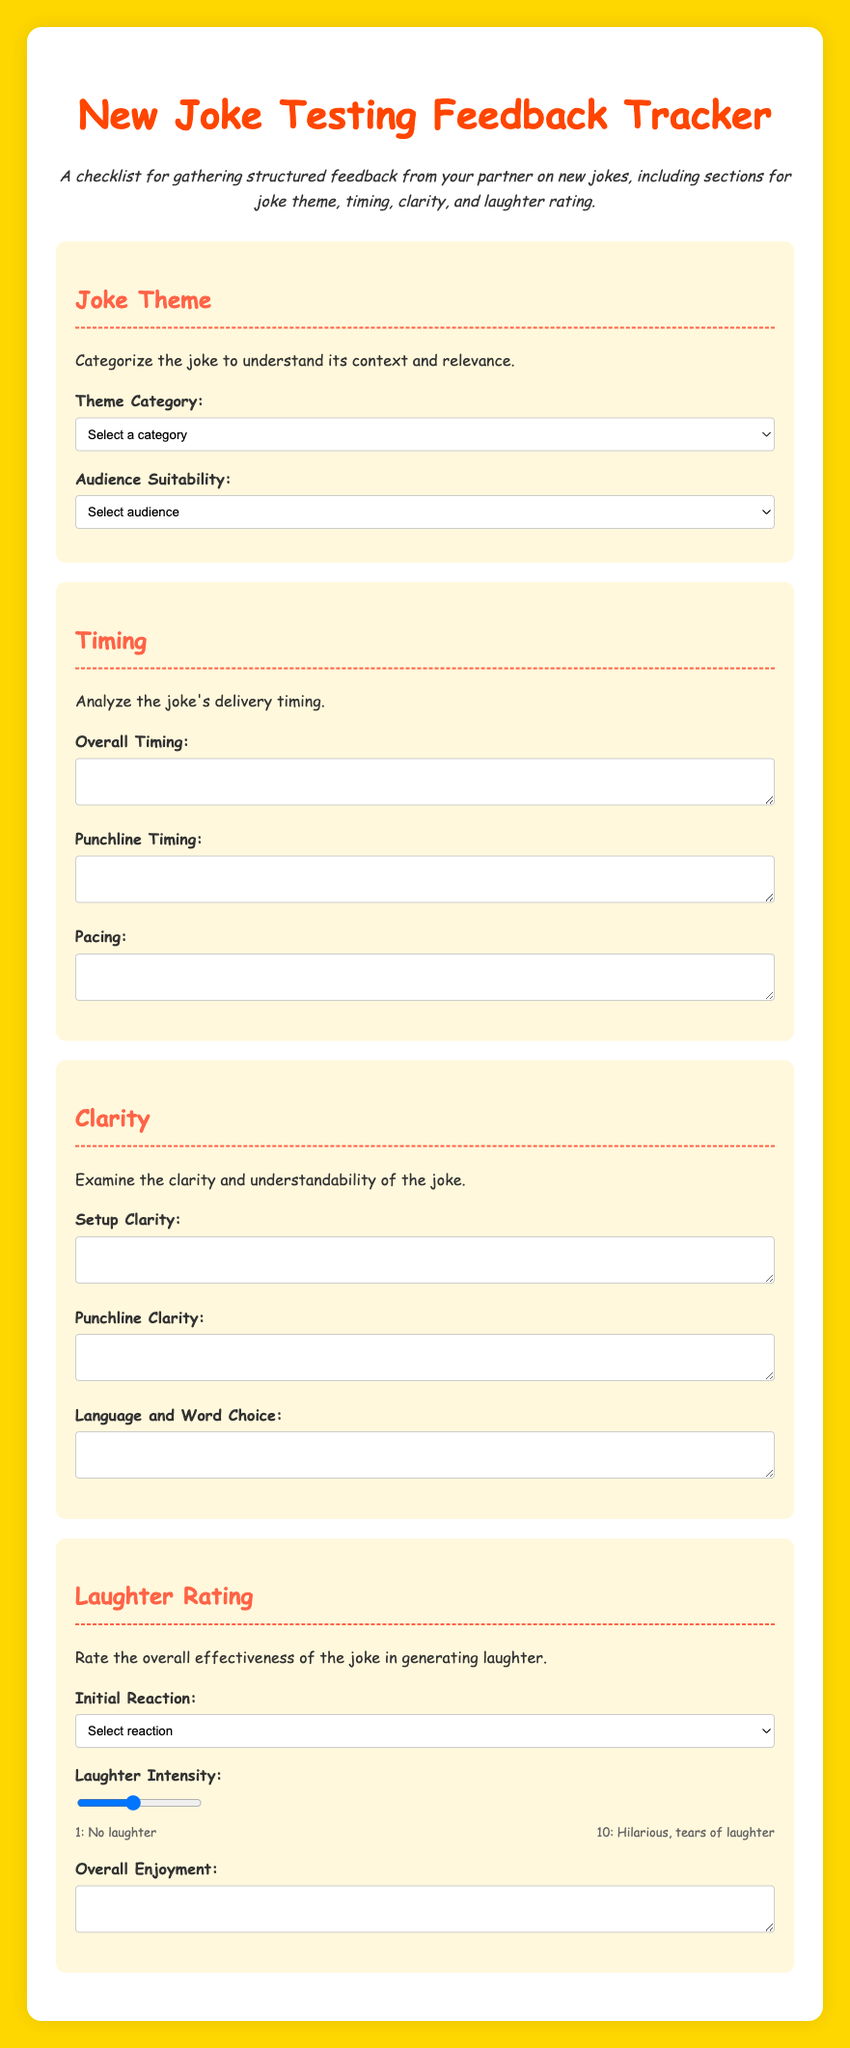What is the title of the document? The title of the document is provided in the header section of the HTML code.
Answer: New Joke Testing Feedback Tracker How many sections are there in the document? Each major topic is categorized into different sections; the code lists four distinct sections.
Answer: 4 What category options are available for Joke Theme? The choices for categorizing a joke theme are outlined in a dropdown list within the document.
Answer: Observational, Self-deprecating, One-liner, Storytelling, Dark What is the highest rating on the laughter intensity scale? The laughter intensity scale values range from 1 to 10, with the highest value being detailed in the description.
Answer: 10 What feedback is requested regarding punchline clarity? The document includes a section specifically designed to encourage feedback on the punchline clarity of jokes.
Answer: Punchline Clarity What type of audience is mentioned for joke suitability? The document identifies different audience types to specify the appropriate suitability for the jokes presented.
Answer: General audience, Adults only, Niche audience 